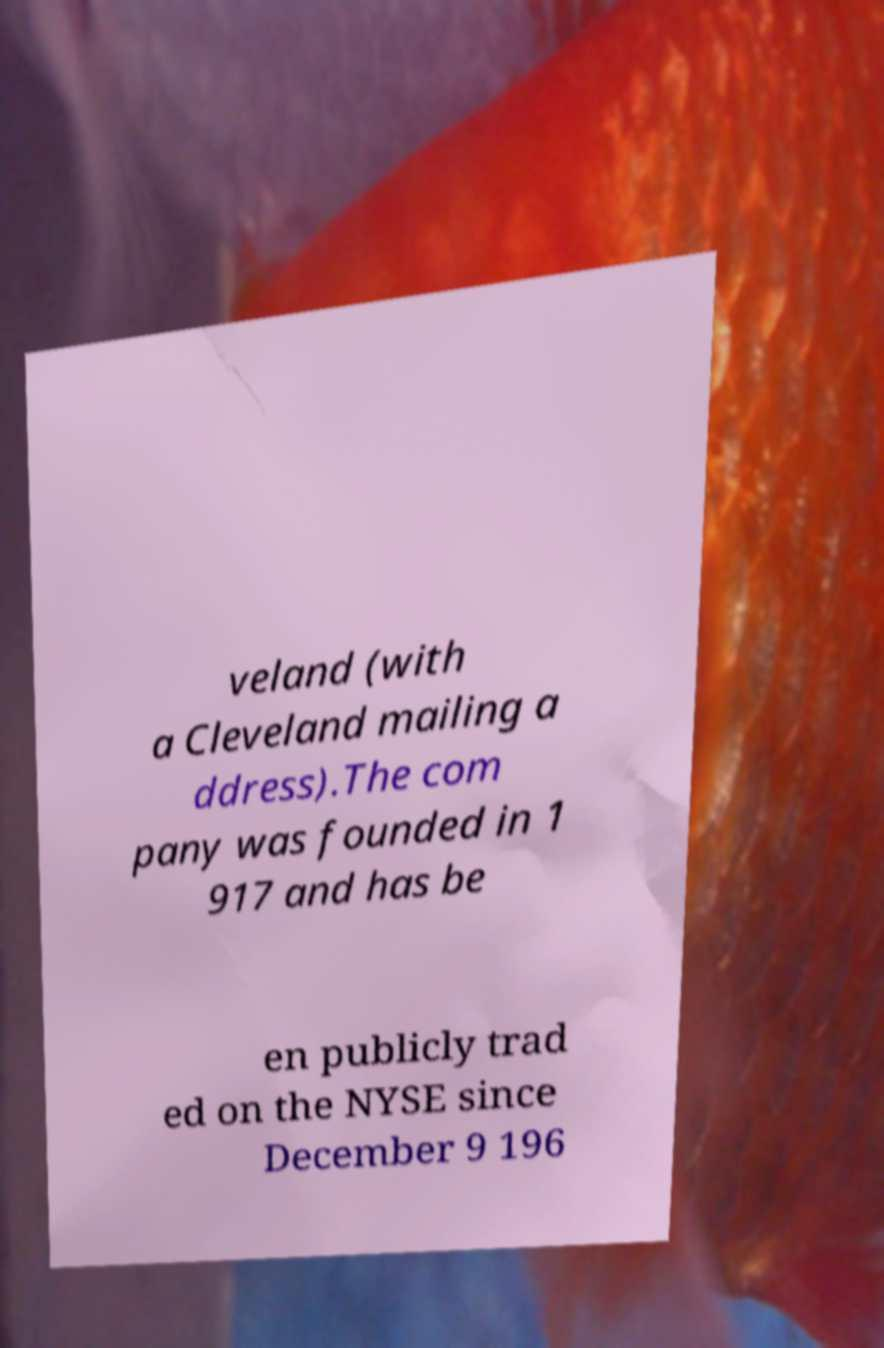Could you extract and type out the text from this image? veland (with a Cleveland mailing a ddress).The com pany was founded in 1 917 and has be en publicly trad ed on the NYSE since December 9 196 